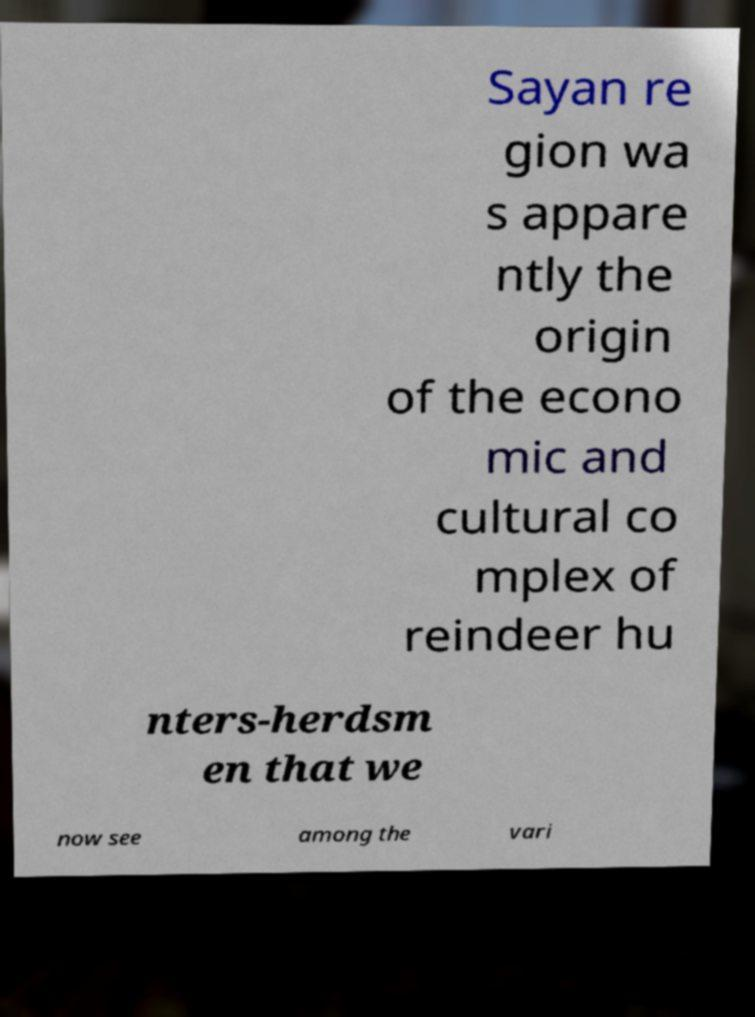For documentation purposes, I need the text within this image transcribed. Could you provide that? Sayan re gion wa s appare ntly the origin of the econo mic and cultural co mplex of reindeer hu nters-herdsm en that we now see among the vari 